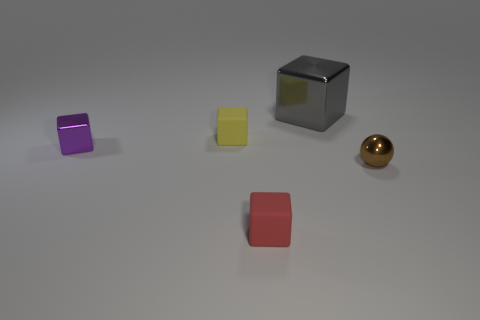Subtract all small cubes. How many cubes are left? 1 Subtract all purple cubes. How many cubes are left? 3 Subtract all green cubes. Subtract all yellow cylinders. How many cubes are left? 4 Add 2 purple blocks. How many objects exist? 7 Subtract all blocks. How many objects are left? 1 Subtract 0 cyan balls. How many objects are left? 5 Subtract all tiny shiny spheres. Subtract all large gray cubes. How many objects are left? 3 Add 3 cubes. How many cubes are left? 7 Add 4 green rubber blocks. How many green rubber blocks exist? 4 